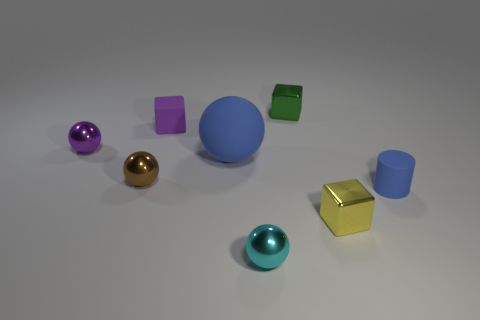Subtract all blue balls. How many balls are left? 3 Subtract 2 balls. How many balls are left? 2 Add 1 purple rubber cylinders. How many objects exist? 9 Subtract all yellow balls. Subtract all red cubes. How many balls are left? 4 Subtract all blocks. How many objects are left? 5 Add 7 green metal blocks. How many green metal blocks are left? 8 Add 5 small brown things. How many small brown things exist? 6 Subtract 1 blue spheres. How many objects are left? 7 Subtract all green metallic balls. Subtract all purple metal things. How many objects are left? 7 